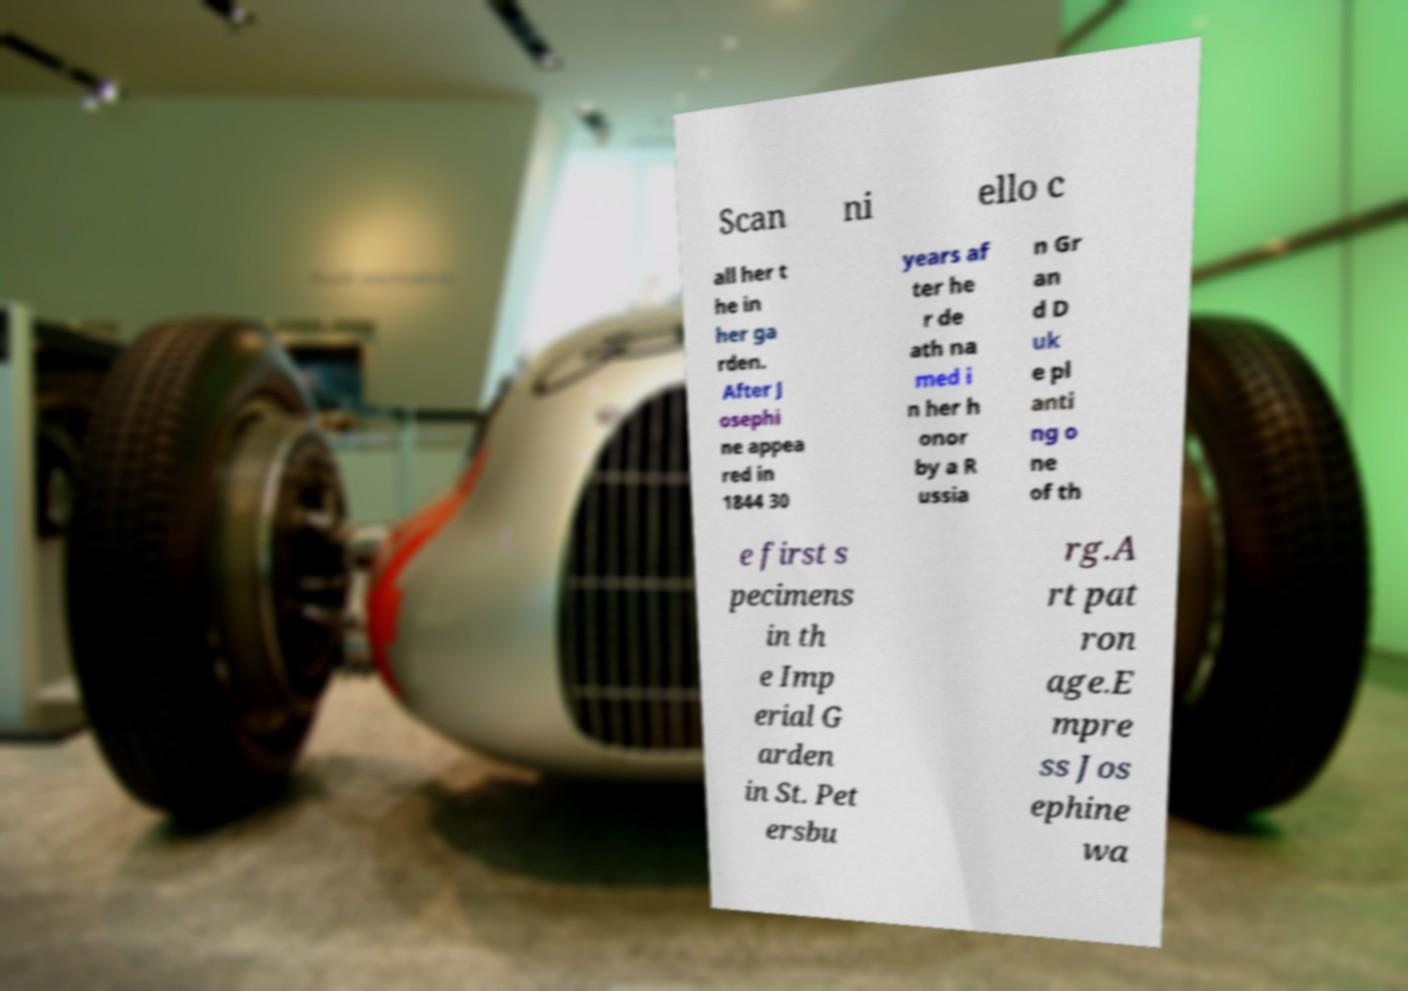Could you assist in decoding the text presented in this image and type it out clearly? Scan ni ello c all her t he in her ga rden. After J osephi ne appea red in 1844 30 years af ter he r de ath na med i n her h onor by a R ussia n Gr an d D uk e pl anti ng o ne of th e first s pecimens in th e Imp erial G arden in St. Pet ersbu rg.A rt pat ron age.E mpre ss Jos ephine wa 